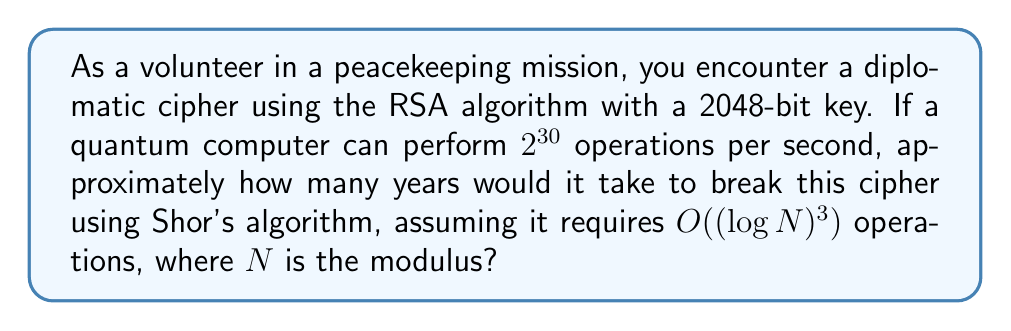Solve this math problem. Let's approach this step-by-step:

1) The RSA algorithm with a 2048-bit key means $N$ is a 2048-bit number.

2) Shor's algorithm has a complexity of $O((\log N)^3)$ operations.

3) For a 2048-bit $N$, $\log N = 2048$.

4) Therefore, the number of operations required is approximately:
   $(\log N)^3 = 2048^3 = 8,589,934,592$

5) The quantum computer can perform $2^{30}$ operations per second.
   $2^{30} = 1,073,741,824$ operations/second

6) Time required:
   $$\text{Time} = \frac{8,589,934,592}{1,073,741,824} \approx 8 \text{ seconds}$$

7) Convert to years:
   $$8 \text{ seconds} = \frac{8}{60 \times 60 \times 24 \times 365.25} \approx 2.54 \times 10^{-7} \text{ years}$$
Answer: $2.54 \times 10^{-7}$ years 